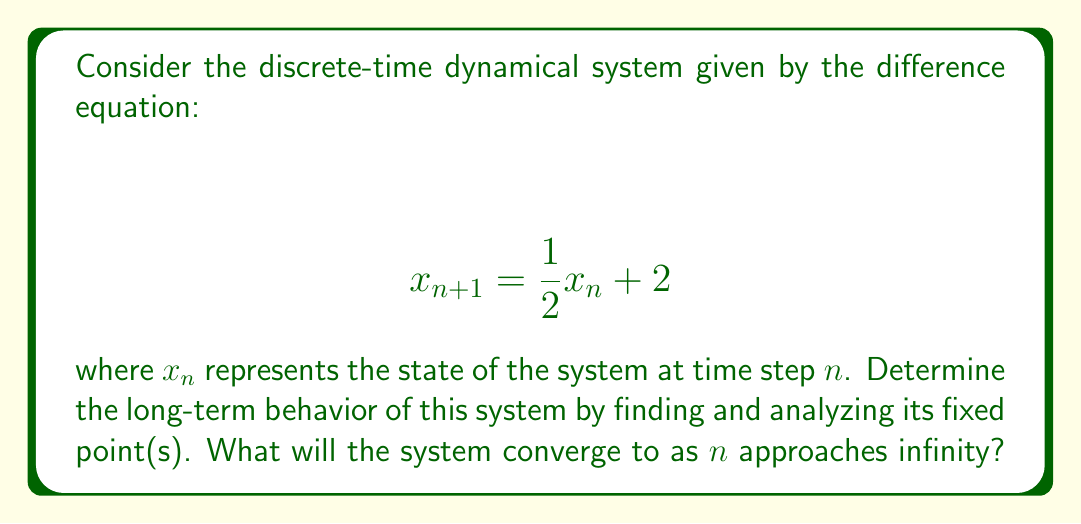Provide a solution to this math problem. Let's approach this step-by-step:

1) To find the fixed point(s), we set $x_{n+1} = x_n = x^*$:

   $$ x^* = \frac{1}{2}x^* + 2 $$

2) Solve for $x^*$:

   $$ x^* - \frac{1}{2}x^* = 2 $$
   $$ \frac{1}{2}x^* = 2 $$
   $$ x^* = 4 $$

3) We've found that the system has a unique fixed point at $x^* = 4$.

4) To determine the stability of this fixed point, we need to evaluate the derivative of the function at the fixed point:

   $$ f(x) = \frac{1}{2}x + 2 $$
   $$ f'(x) = \frac{1}{2} $$

5) The stability criterion for a discrete-time system is:
   - If $|f'(x^*)| < 1$, the fixed point is stable.
   - If $|f'(x^*)| > 1$, the fixed point is unstable.
   - If $|f'(x^*)| = 1$, the fixed point is neutral (neither stable nor unstable).

6) In this case, $|f'(x^*)| = |\frac{1}{2}| = 0.5 < 1$, so the fixed point is stable.

7) For a stable fixed point in a linear system like this, the system will converge to the fixed point regardless of the initial condition.

Therefore, as $n$ approaches infinity, the system will converge to the fixed point $x^* = 4$.
Answer: The system converges to 4. 